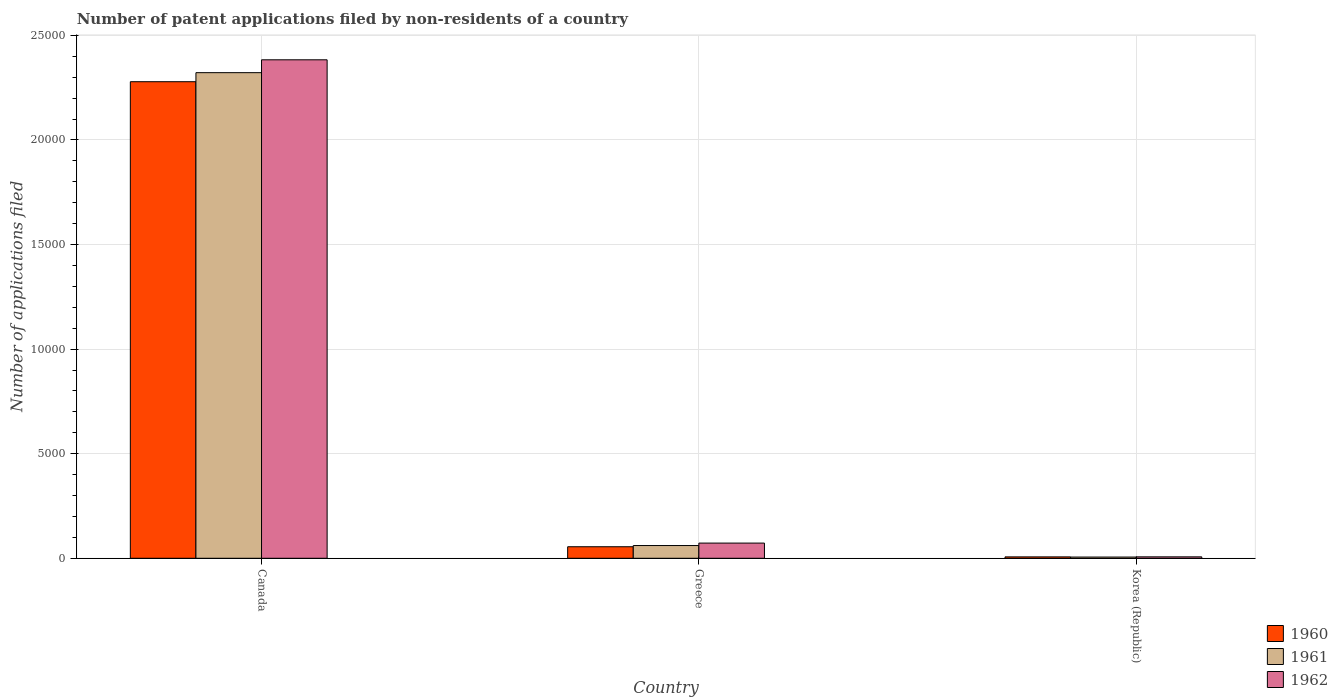How many different coloured bars are there?
Offer a very short reply. 3. How many groups of bars are there?
Your response must be concise. 3. How many bars are there on the 2nd tick from the right?
Your answer should be compact. 3. What is the label of the 3rd group of bars from the left?
Your answer should be compact. Korea (Republic). What is the number of applications filed in 1962 in Greece?
Your answer should be compact. 726. Across all countries, what is the maximum number of applications filed in 1960?
Make the answer very short. 2.28e+04. Across all countries, what is the minimum number of applications filed in 1960?
Provide a succinct answer. 66. In which country was the number of applications filed in 1960 maximum?
Offer a very short reply. Canada. In which country was the number of applications filed in 1961 minimum?
Your answer should be very brief. Korea (Republic). What is the total number of applications filed in 1962 in the graph?
Offer a terse response. 2.46e+04. What is the difference between the number of applications filed in 1961 in Canada and that in Greece?
Ensure brevity in your answer.  2.26e+04. What is the difference between the number of applications filed in 1962 in Greece and the number of applications filed in 1961 in Korea (Republic)?
Provide a succinct answer. 668. What is the average number of applications filed in 1960 per country?
Your answer should be compact. 7801. What is the difference between the number of applications filed of/in 1962 and number of applications filed of/in 1960 in Greece?
Offer a very short reply. 175. What is the ratio of the number of applications filed in 1960 in Canada to that in Korea (Republic)?
Make the answer very short. 345.24. What is the difference between the highest and the second highest number of applications filed in 1961?
Keep it short and to the point. 551. What is the difference between the highest and the lowest number of applications filed in 1960?
Provide a short and direct response. 2.27e+04. What does the 2nd bar from the left in Korea (Republic) represents?
Give a very brief answer. 1961. What does the 3rd bar from the right in Korea (Republic) represents?
Offer a very short reply. 1960. How many bars are there?
Your response must be concise. 9. Does the graph contain any zero values?
Your answer should be compact. No. Does the graph contain grids?
Offer a very short reply. Yes. Where does the legend appear in the graph?
Make the answer very short. Bottom right. What is the title of the graph?
Provide a succinct answer. Number of patent applications filed by non-residents of a country. What is the label or title of the Y-axis?
Ensure brevity in your answer.  Number of applications filed. What is the Number of applications filed of 1960 in Canada?
Give a very brief answer. 2.28e+04. What is the Number of applications filed of 1961 in Canada?
Ensure brevity in your answer.  2.32e+04. What is the Number of applications filed of 1962 in Canada?
Your answer should be very brief. 2.38e+04. What is the Number of applications filed in 1960 in Greece?
Your answer should be compact. 551. What is the Number of applications filed in 1961 in Greece?
Make the answer very short. 609. What is the Number of applications filed of 1962 in Greece?
Ensure brevity in your answer.  726. What is the Number of applications filed of 1960 in Korea (Republic)?
Offer a terse response. 66. What is the Number of applications filed in 1961 in Korea (Republic)?
Your answer should be compact. 58. Across all countries, what is the maximum Number of applications filed of 1960?
Your answer should be compact. 2.28e+04. Across all countries, what is the maximum Number of applications filed of 1961?
Provide a succinct answer. 2.32e+04. Across all countries, what is the maximum Number of applications filed in 1962?
Your answer should be very brief. 2.38e+04. Across all countries, what is the minimum Number of applications filed of 1960?
Ensure brevity in your answer.  66. Across all countries, what is the minimum Number of applications filed of 1961?
Offer a very short reply. 58. Across all countries, what is the minimum Number of applications filed in 1962?
Provide a short and direct response. 68. What is the total Number of applications filed of 1960 in the graph?
Make the answer very short. 2.34e+04. What is the total Number of applications filed of 1961 in the graph?
Provide a succinct answer. 2.39e+04. What is the total Number of applications filed in 1962 in the graph?
Give a very brief answer. 2.46e+04. What is the difference between the Number of applications filed in 1960 in Canada and that in Greece?
Your answer should be compact. 2.22e+04. What is the difference between the Number of applications filed in 1961 in Canada and that in Greece?
Keep it short and to the point. 2.26e+04. What is the difference between the Number of applications filed of 1962 in Canada and that in Greece?
Give a very brief answer. 2.31e+04. What is the difference between the Number of applications filed of 1960 in Canada and that in Korea (Republic)?
Your answer should be very brief. 2.27e+04. What is the difference between the Number of applications filed of 1961 in Canada and that in Korea (Republic)?
Provide a short and direct response. 2.32e+04. What is the difference between the Number of applications filed in 1962 in Canada and that in Korea (Republic)?
Offer a terse response. 2.38e+04. What is the difference between the Number of applications filed in 1960 in Greece and that in Korea (Republic)?
Provide a short and direct response. 485. What is the difference between the Number of applications filed in 1961 in Greece and that in Korea (Republic)?
Make the answer very short. 551. What is the difference between the Number of applications filed in 1962 in Greece and that in Korea (Republic)?
Keep it short and to the point. 658. What is the difference between the Number of applications filed in 1960 in Canada and the Number of applications filed in 1961 in Greece?
Make the answer very short. 2.22e+04. What is the difference between the Number of applications filed of 1960 in Canada and the Number of applications filed of 1962 in Greece?
Offer a terse response. 2.21e+04. What is the difference between the Number of applications filed of 1961 in Canada and the Number of applications filed of 1962 in Greece?
Your answer should be very brief. 2.25e+04. What is the difference between the Number of applications filed of 1960 in Canada and the Number of applications filed of 1961 in Korea (Republic)?
Ensure brevity in your answer.  2.27e+04. What is the difference between the Number of applications filed of 1960 in Canada and the Number of applications filed of 1962 in Korea (Republic)?
Provide a short and direct response. 2.27e+04. What is the difference between the Number of applications filed of 1961 in Canada and the Number of applications filed of 1962 in Korea (Republic)?
Your answer should be compact. 2.32e+04. What is the difference between the Number of applications filed of 1960 in Greece and the Number of applications filed of 1961 in Korea (Republic)?
Provide a short and direct response. 493. What is the difference between the Number of applications filed in 1960 in Greece and the Number of applications filed in 1962 in Korea (Republic)?
Provide a succinct answer. 483. What is the difference between the Number of applications filed of 1961 in Greece and the Number of applications filed of 1962 in Korea (Republic)?
Make the answer very short. 541. What is the average Number of applications filed of 1960 per country?
Your answer should be compact. 7801. What is the average Number of applications filed in 1961 per country?
Provide a short and direct response. 7962. What is the average Number of applications filed in 1962 per country?
Provide a short and direct response. 8209.33. What is the difference between the Number of applications filed of 1960 and Number of applications filed of 1961 in Canada?
Make the answer very short. -433. What is the difference between the Number of applications filed of 1960 and Number of applications filed of 1962 in Canada?
Your answer should be compact. -1048. What is the difference between the Number of applications filed of 1961 and Number of applications filed of 1962 in Canada?
Your answer should be very brief. -615. What is the difference between the Number of applications filed of 1960 and Number of applications filed of 1961 in Greece?
Give a very brief answer. -58. What is the difference between the Number of applications filed of 1960 and Number of applications filed of 1962 in Greece?
Keep it short and to the point. -175. What is the difference between the Number of applications filed in 1961 and Number of applications filed in 1962 in Greece?
Provide a short and direct response. -117. What is the difference between the Number of applications filed of 1960 and Number of applications filed of 1961 in Korea (Republic)?
Offer a very short reply. 8. What is the difference between the Number of applications filed in 1960 and Number of applications filed in 1962 in Korea (Republic)?
Give a very brief answer. -2. What is the ratio of the Number of applications filed of 1960 in Canada to that in Greece?
Make the answer very short. 41.35. What is the ratio of the Number of applications filed of 1961 in Canada to that in Greece?
Provide a short and direct response. 38.13. What is the ratio of the Number of applications filed in 1962 in Canada to that in Greece?
Ensure brevity in your answer.  32.83. What is the ratio of the Number of applications filed of 1960 in Canada to that in Korea (Republic)?
Ensure brevity in your answer.  345.24. What is the ratio of the Number of applications filed of 1961 in Canada to that in Korea (Republic)?
Ensure brevity in your answer.  400.33. What is the ratio of the Number of applications filed of 1962 in Canada to that in Korea (Republic)?
Ensure brevity in your answer.  350.5. What is the ratio of the Number of applications filed in 1960 in Greece to that in Korea (Republic)?
Make the answer very short. 8.35. What is the ratio of the Number of applications filed in 1961 in Greece to that in Korea (Republic)?
Your answer should be compact. 10.5. What is the ratio of the Number of applications filed in 1962 in Greece to that in Korea (Republic)?
Ensure brevity in your answer.  10.68. What is the difference between the highest and the second highest Number of applications filed of 1960?
Your response must be concise. 2.22e+04. What is the difference between the highest and the second highest Number of applications filed in 1961?
Offer a terse response. 2.26e+04. What is the difference between the highest and the second highest Number of applications filed in 1962?
Make the answer very short. 2.31e+04. What is the difference between the highest and the lowest Number of applications filed in 1960?
Offer a very short reply. 2.27e+04. What is the difference between the highest and the lowest Number of applications filed of 1961?
Offer a very short reply. 2.32e+04. What is the difference between the highest and the lowest Number of applications filed in 1962?
Provide a succinct answer. 2.38e+04. 